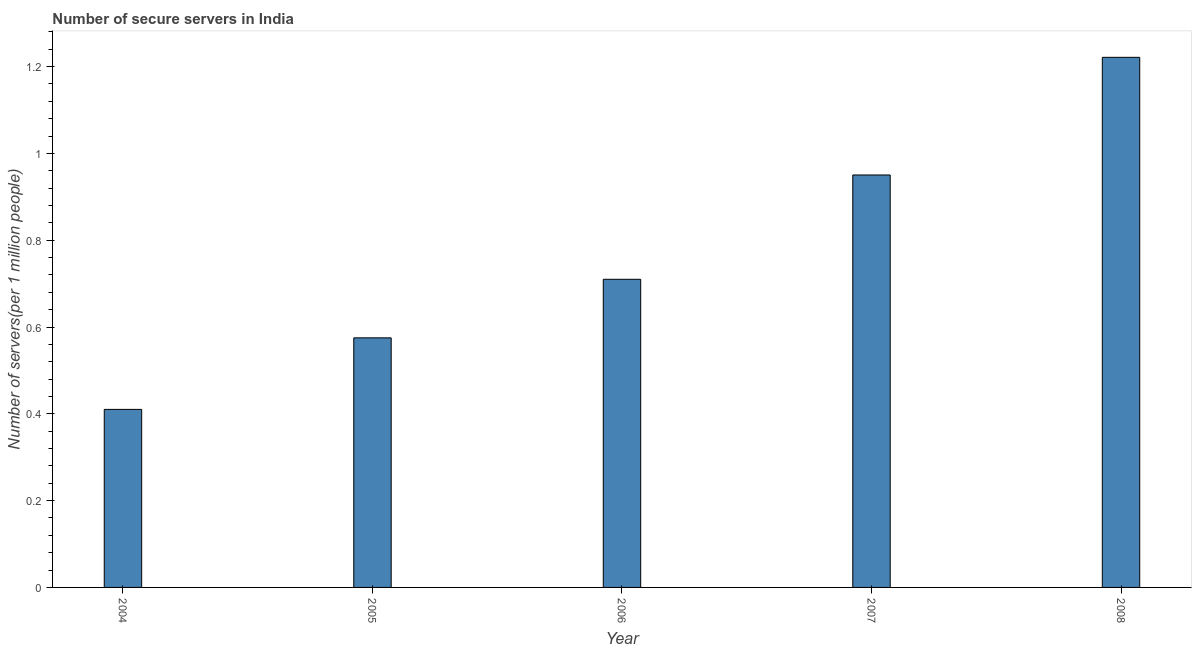Does the graph contain any zero values?
Keep it short and to the point. No. What is the title of the graph?
Your response must be concise. Number of secure servers in India. What is the label or title of the X-axis?
Your answer should be compact. Year. What is the label or title of the Y-axis?
Make the answer very short. Number of servers(per 1 million people). What is the number of secure internet servers in 2007?
Offer a terse response. 0.95. Across all years, what is the maximum number of secure internet servers?
Offer a terse response. 1.22. Across all years, what is the minimum number of secure internet servers?
Ensure brevity in your answer.  0.41. In which year was the number of secure internet servers maximum?
Keep it short and to the point. 2008. What is the sum of the number of secure internet servers?
Provide a short and direct response. 3.87. What is the difference between the number of secure internet servers in 2007 and 2008?
Keep it short and to the point. -0.27. What is the average number of secure internet servers per year?
Your answer should be compact. 0.77. What is the median number of secure internet servers?
Your response must be concise. 0.71. In how many years, is the number of secure internet servers greater than 0.32 ?
Keep it short and to the point. 5. Do a majority of the years between 2006 and 2004 (inclusive) have number of secure internet servers greater than 1.08 ?
Offer a terse response. Yes. What is the ratio of the number of secure internet servers in 2004 to that in 2005?
Provide a succinct answer. 0.71. Is the number of secure internet servers in 2006 less than that in 2008?
Keep it short and to the point. Yes. What is the difference between the highest and the second highest number of secure internet servers?
Offer a very short reply. 0.27. What is the difference between the highest and the lowest number of secure internet servers?
Provide a short and direct response. 0.81. How many bars are there?
Keep it short and to the point. 5. How many years are there in the graph?
Provide a succinct answer. 5. What is the difference between two consecutive major ticks on the Y-axis?
Your response must be concise. 0.2. Are the values on the major ticks of Y-axis written in scientific E-notation?
Give a very brief answer. No. What is the Number of servers(per 1 million people) in 2004?
Your answer should be very brief. 0.41. What is the Number of servers(per 1 million people) in 2005?
Give a very brief answer. 0.58. What is the Number of servers(per 1 million people) in 2006?
Keep it short and to the point. 0.71. What is the Number of servers(per 1 million people) of 2007?
Offer a very short reply. 0.95. What is the Number of servers(per 1 million people) in 2008?
Provide a succinct answer. 1.22. What is the difference between the Number of servers(per 1 million people) in 2004 and 2005?
Provide a short and direct response. -0.16. What is the difference between the Number of servers(per 1 million people) in 2004 and 2006?
Offer a very short reply. -0.3. What is the difference between the Number of servers(per 1 million people) in 2004 and 2007?
Make the answer very short. -0.54. What is the difference between the Number of servers(per 1 million people) in 2004 and 2008?
Offer a very short reply. -0.81. What is the difference between the Number of servers(per 1 million people) in 2005 and 2006?
Offer a very short reply. -0.13. What is the difference between the Number of servers(per 1 million people) in 2005 and 2007?
Make the answer very short. -0.38. What is the difference between the Number of servers(per 1 million people) in 2005 and 2008?
Offer a terse response. -0.65. What is the difference between the Number of servers(per 1 million people) in 2006 and 2007?
Give a very brief answer. -0.24. What is the difference between the Number of servers(per 1 million people) in 2006 and 2008?
Make the answer very short. -0.51. What is the difference between the Number of servers(per 1 million people) in 2007 and 2008?
Your answer should be very brief. -0.27. What is the ratio of the Number of servers(per 1 million people) in 2004 to that in 2005?
Provide a short and direct response. 0.71. What is the ratio of the Number of servers(per 1 million people) in 2004 to that in 2006?
Your response must be concise. 0.58. What is the ratio of the Number of servers(per 1 million people) in 2004 to that in 2007?
Ensure brevity in your answer.  0.43. What is the ratio of the Number of servers(per 1 million people) in 2004 to that in 2008?
Your answer should be very brief. 0.34. What is the ratio of the Number of servers(per 1 million people) in 2005 to that in 2006?
Keep it short and to the point. 0.81. What is the ratio of the Number of servers(per 1 million people) in 2005 to that in 2007?
Give a very brief answer. 0.6. What is the ratio of the Number of servers(per 1 million people) in 2005 to that in 2008?
Keep it short and to the point. 0.47. What is the ratio of the Number of servers(per 1 million people) in 2006 to that in 2007?
Provide a succinct answer. 0.75. What is the ratio of the Number of servers(per 1 million people) in 2006 to that in 2008?
Your answer should be very brief. 0.58. What is the ratio of the Number of servers(per 1 million people) in 2007 to that in 2008?
Offer a very short reply. 0.78. 